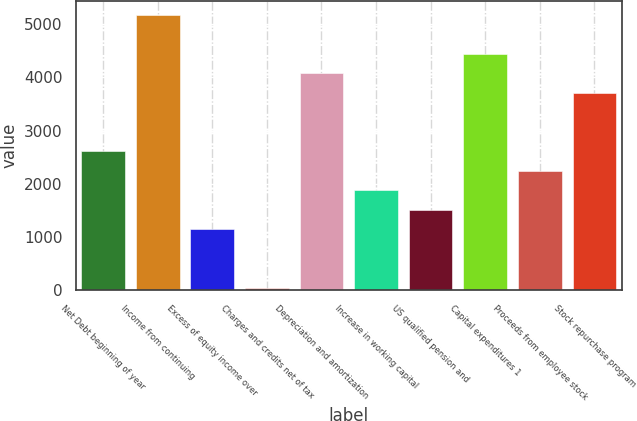Convert chart to OTSL. <chart><loc_0><loc_0><loc_500><loc_500><bar_chart><fcel>Net Debt beginning of year<fcel>Income from continuing<fcel>Excess of equity income over<fcel>Charges and credits net of tax<fcel>Depreciation and amortization<fcel>Increase in working capital<fcel>US qualified pension and<fcel>Capital expenditures 1<fcel>Proceeds from employee stock<fcel>Stock repurchase program<nl><fcel>2609.9<fcel>5176.8<fcel>1143.1<fcel>43<fcel>4076.7<fcel>1876.5<fcel>1509.8<fcel>4443.4<fcel>2243.2<fcel>3710<nl></chart> 